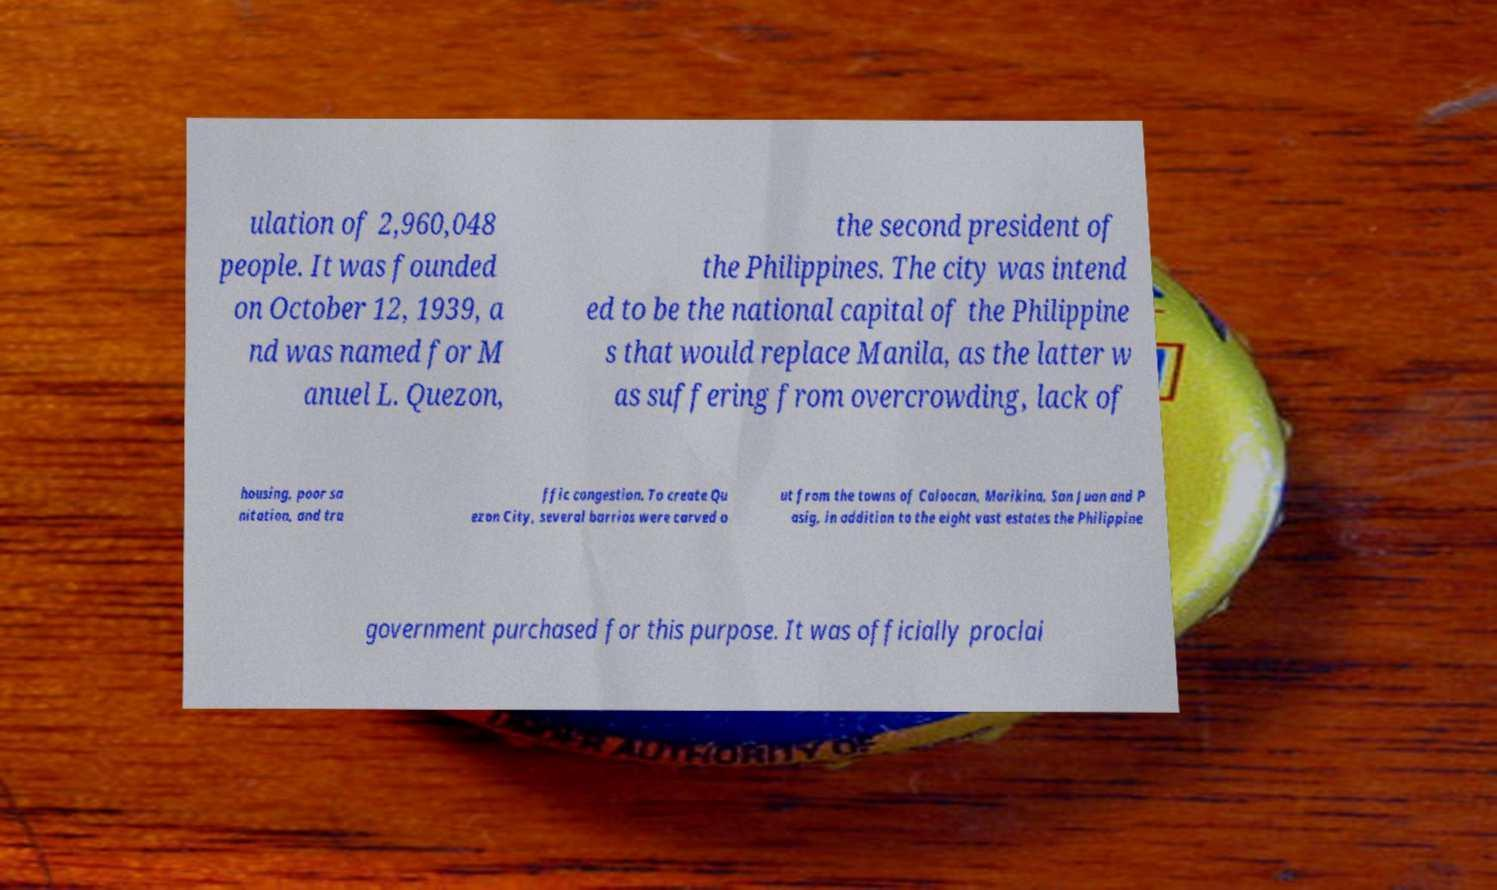Can you accurately transcribe the text from the provided image for me? ulation of 2,960,048 people. It was founded on October 12, 1939, a nd was named for M anuel L. Quezon, the second president of the Philippines. The city was intend ed to be the national capital of the Philippine s that would replace Manila, as the latter w as suffering from overcrowding, lack of housing, poor sa nitation, and tra ffic congestion. To create Qu ezon City, several barrios were carved o ut from the towns of Caloocan, Marikina, San Juan and P asig, in addition to the eight vast estates the Philippine government purchased for this purpose. It was officially proclai 